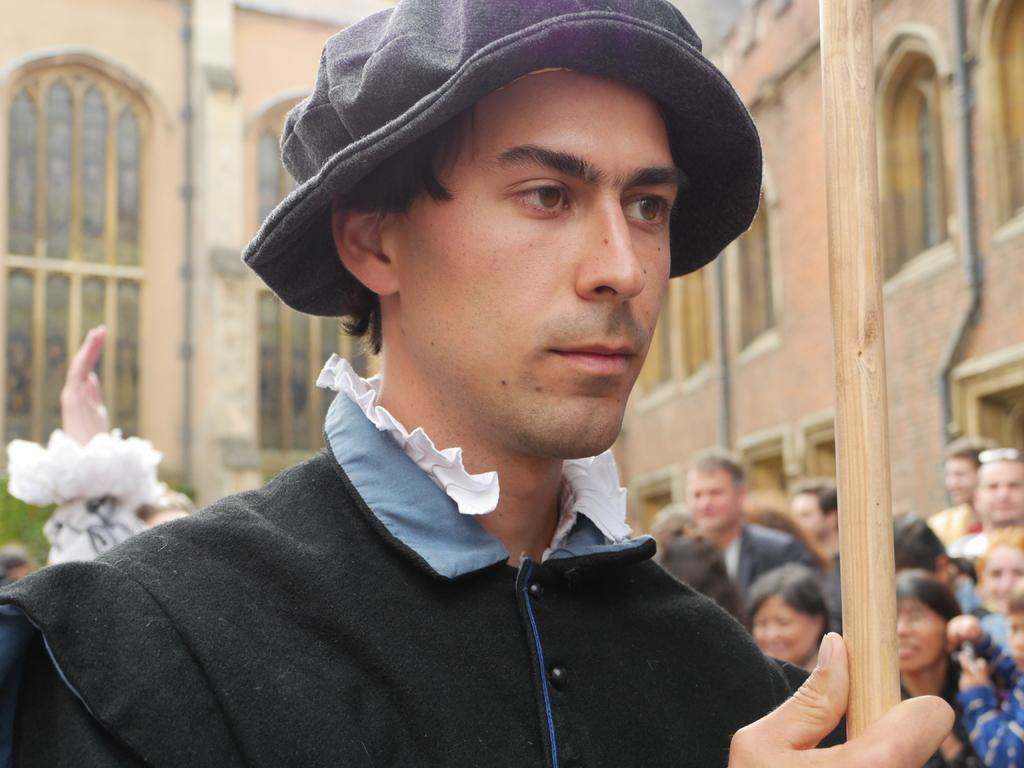Describe this image in one or two sentences. In this picture we can see a man wore a cap and holding a stick with his hand and at the back of him we can see a group of people and in the background we can see windows, walls, pipes. 